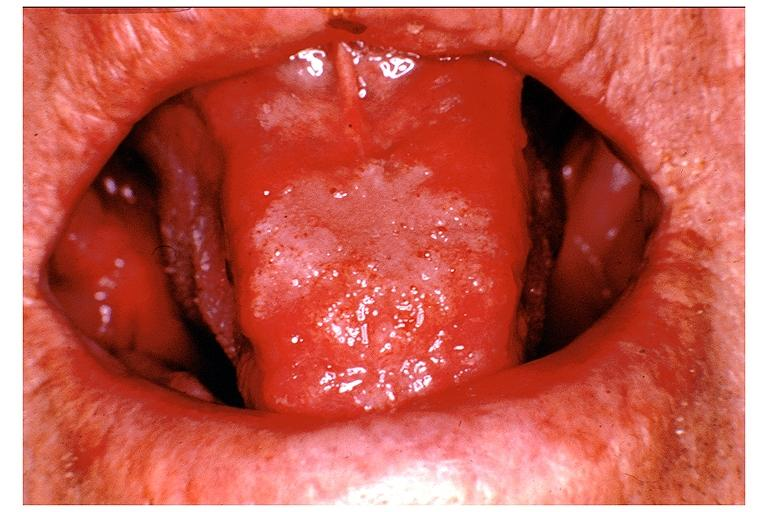where is this?
Answer the question using a single word or phrase. Oral 